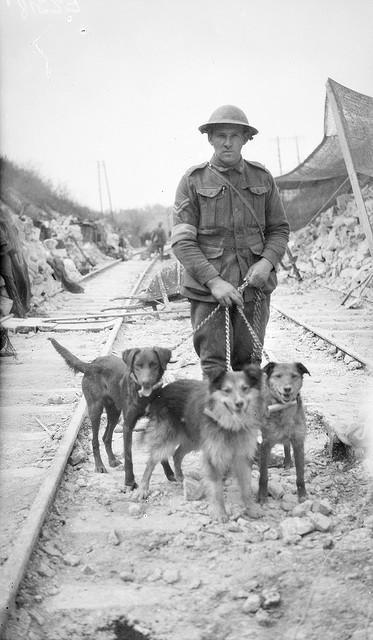How many dogs are in the photo?
Give a very brief answer. 3. How many dogs are there?
Give a very brief answer. 3. 